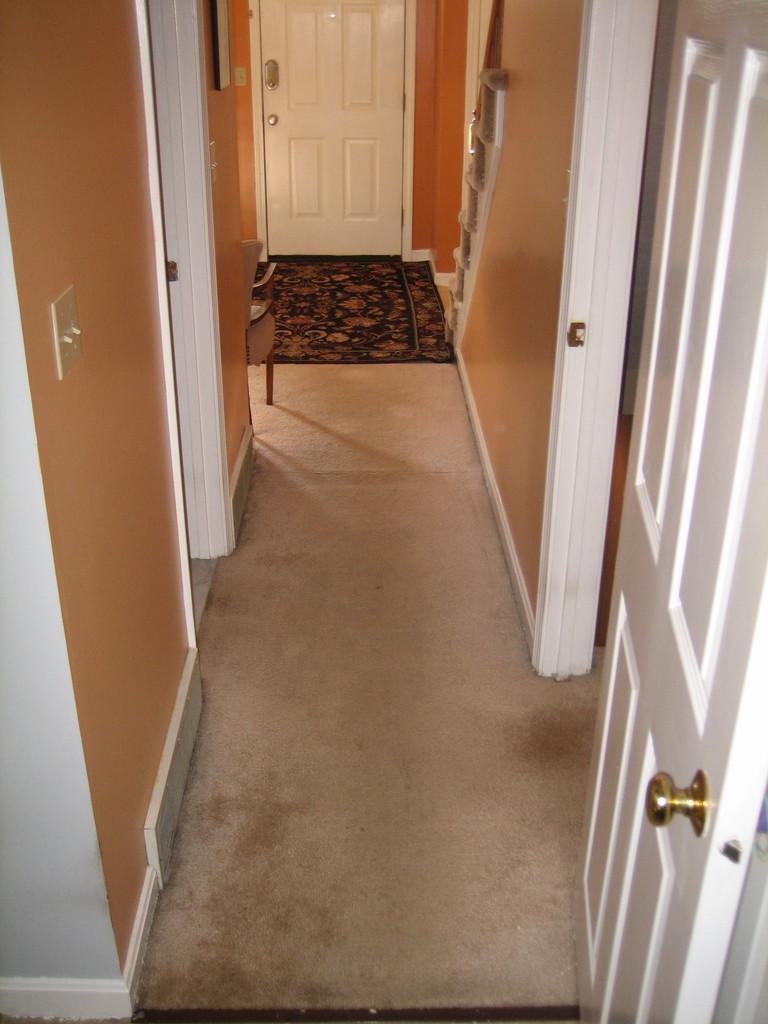Could you give a brief overview of what you see in this image? In this picture we can see door, walls, chair and objects. In the background of the image we can see a mat on the floor and door. 